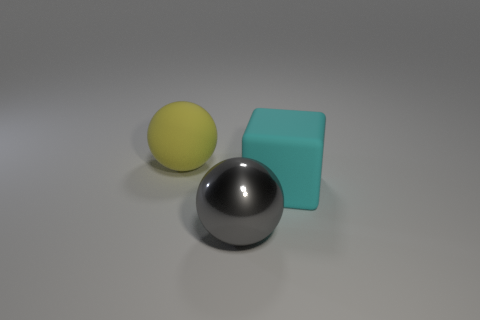Is the large rubber sphere the same color as the big block?
Offer a very short reply. No. Is the sphere that is behind the big shiny thing made of the same material as the sphere on the right side of the big yellow object?
Provide a short and direct response. No. How many things are large purple metallic cylinders or large rubber things behind the big cyan matte block?
Provide a succinct answer. 1. Is there anything else that is made of the same material as the yellow sphere?
Provide a short and direct response. Yes. What is the big yellow object made of?
Your answer should be compact. Rubber. Does the cyan thing have the same material as the gray thing?
Provide a short and direct response. No. How many rubber objects are big gray things or large green cylinders?
Make the answer very short. 0. What shape is the big rubber object behind the cyan matte thing?
Your response must be concise. Sphere. There is a ball that is made of the same material as the large cyan thing; what is its size?
Keep it short and to the point. Large. What shape is the object that is behind the big gray metal thing and in front of the large yellow thing?
Your answer should be very brief. Cube. 